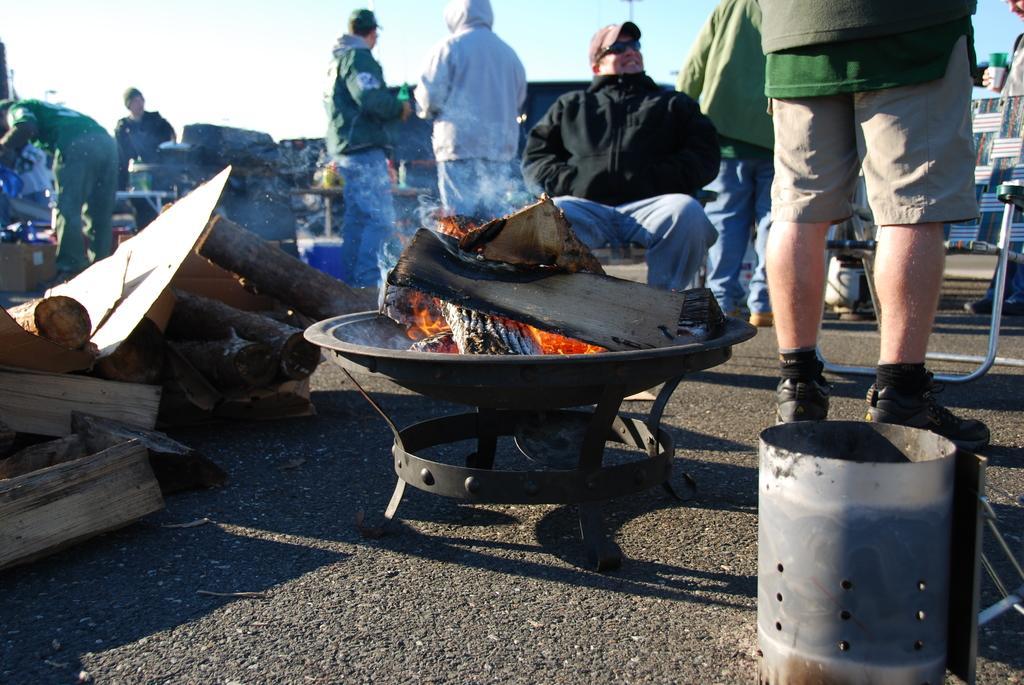Can you describe this image briefly? In this image I can see the ground, few wooden logs on the ground, a bowl in which I can see few burning wood and few persons standing and a person sitting. In the background I can see a chair and the sky. 